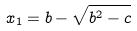Convert formula to latex. <formula><loc_0><loc_0><loc_500><loc_500>x _ { 1 } = b - \sqrt { b ^ { 2 } - c }</formula> 